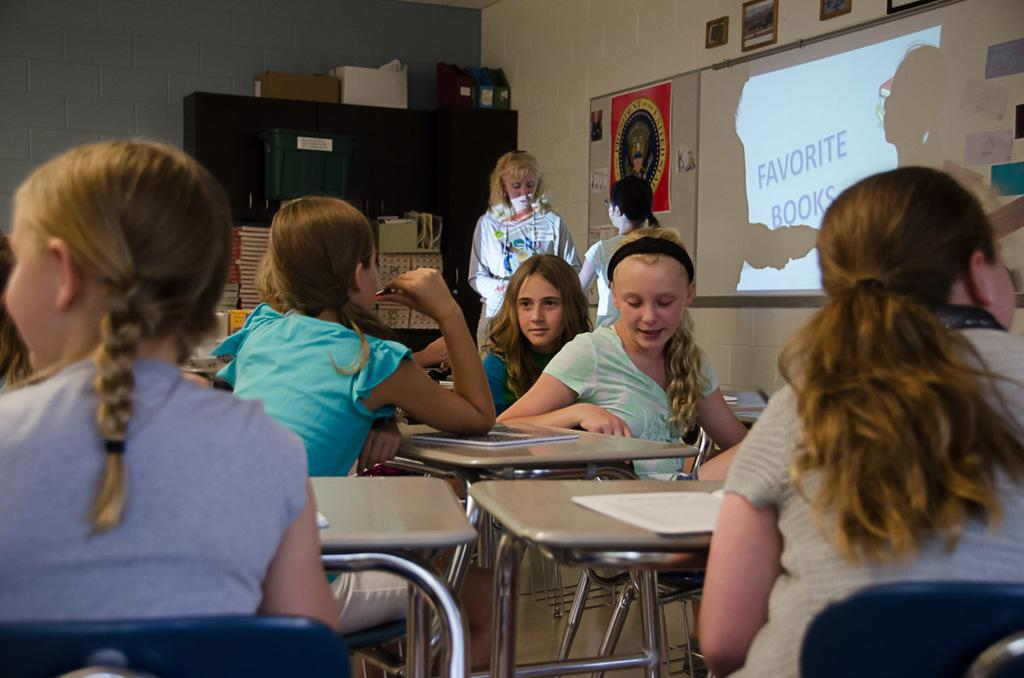What are the people in the image doing? The people in the image are sitting on chairs. What can be seen on the wall in the background of the image? There is a projector screen on a wall in the background of the image. Can you see a snake slithering on the floor in the image? There is no snake present in the image. 